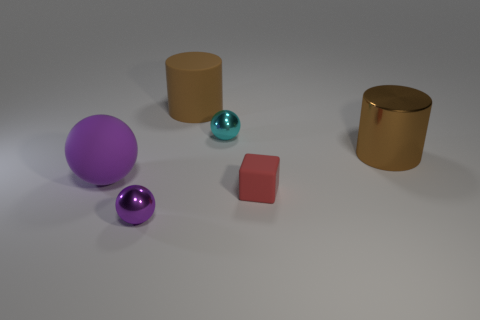Subtract all metallic spheres. How many spheres are left? 1 Add 1 big purple rubber objects. How many objects exist? 7 Subtract all cyan balls. How many balls are left? 2 Subtract all cyan cylinders. How many purple balls are left? 2 Subtract 1 cylinders. How many cylinders are left? 1 Subtract 1 red blocks. How many objects are left? 5 Subtract all cylinders. How many objects are left? 4 Subtract all gray balls. Subtract all brown cubes. How many balls are left? 3 Subtract all small red rubber blocks. Subtract all brown rubber objects. How many objects are left? 4 Add 3 tiny purple metallic balls. How many tiny purple metallic balls are left? 4 